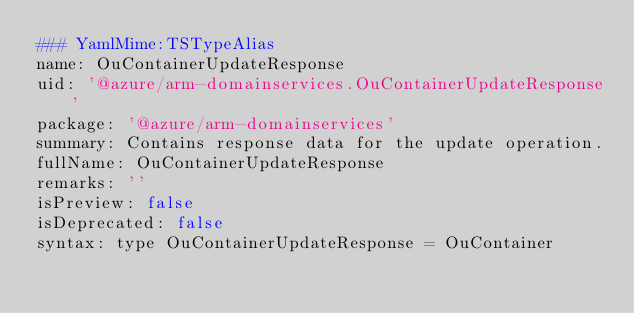<code> <loc_0><loc_0><loc_500><loc_500><_YAML_>### YamlMime:TSTypeAlias
name: OuContainerUpdateResponse
uid: '@azure/arm-domainservices.OuContainerUpdateResponse'
package: '@azure/arm-domainservices'
summary: Contains response data for the update operation.
fullName: OuContainerUpdateResponse
remarks: ''
isPreview: false
isDeprecated: false
syntax: type OuContainerUpdateResponse = OuContainer
</code> 